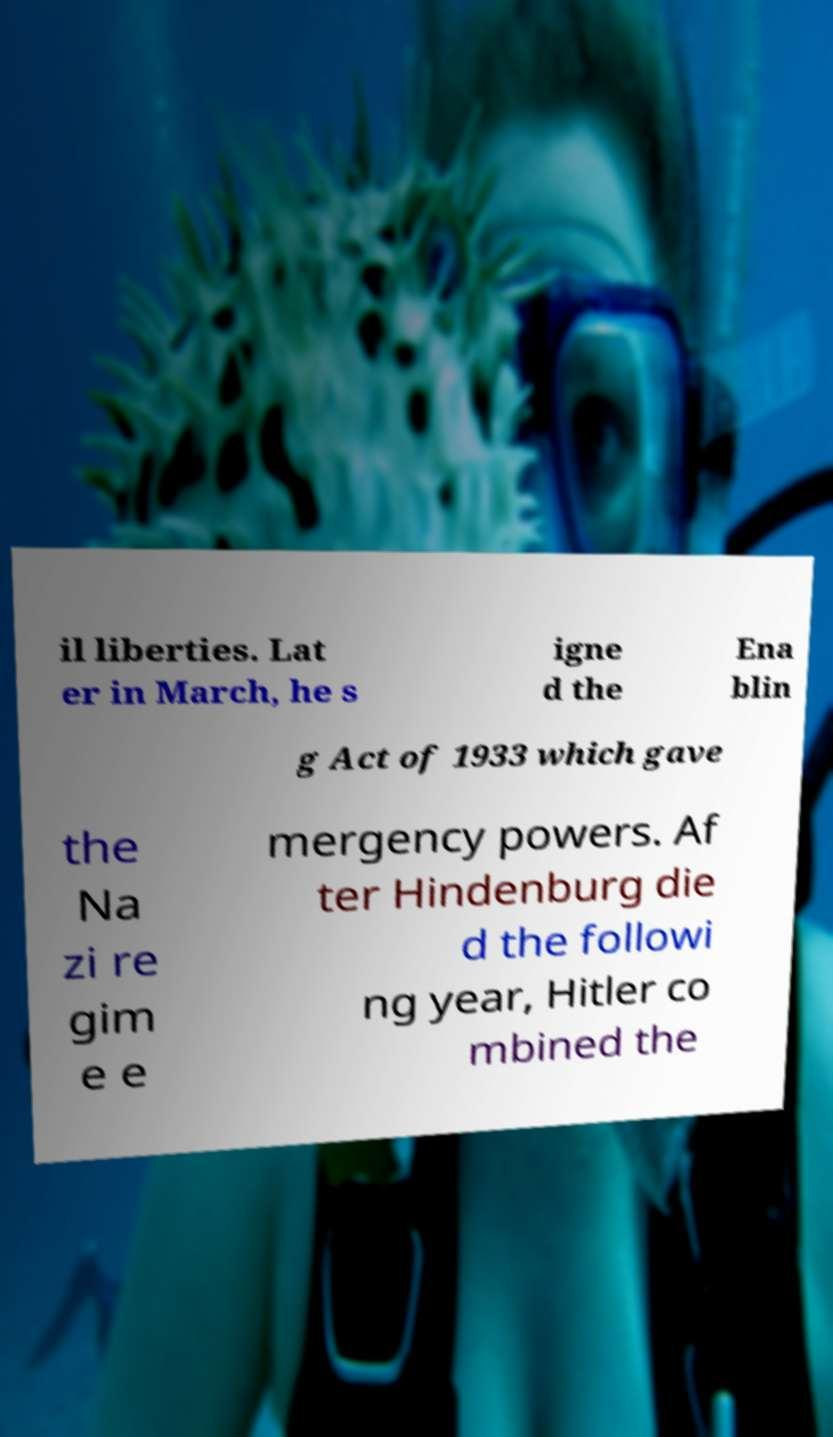Could you assist in decoding the text presented in this image and type it out clearly? il liberties. Lat er in March, he s igne d the Ena blin g Act of 1933 which gave the Na zi re gim e e mergency powers. Af ter Hindenburg die d the followi ng year, Hitler co mbined the 